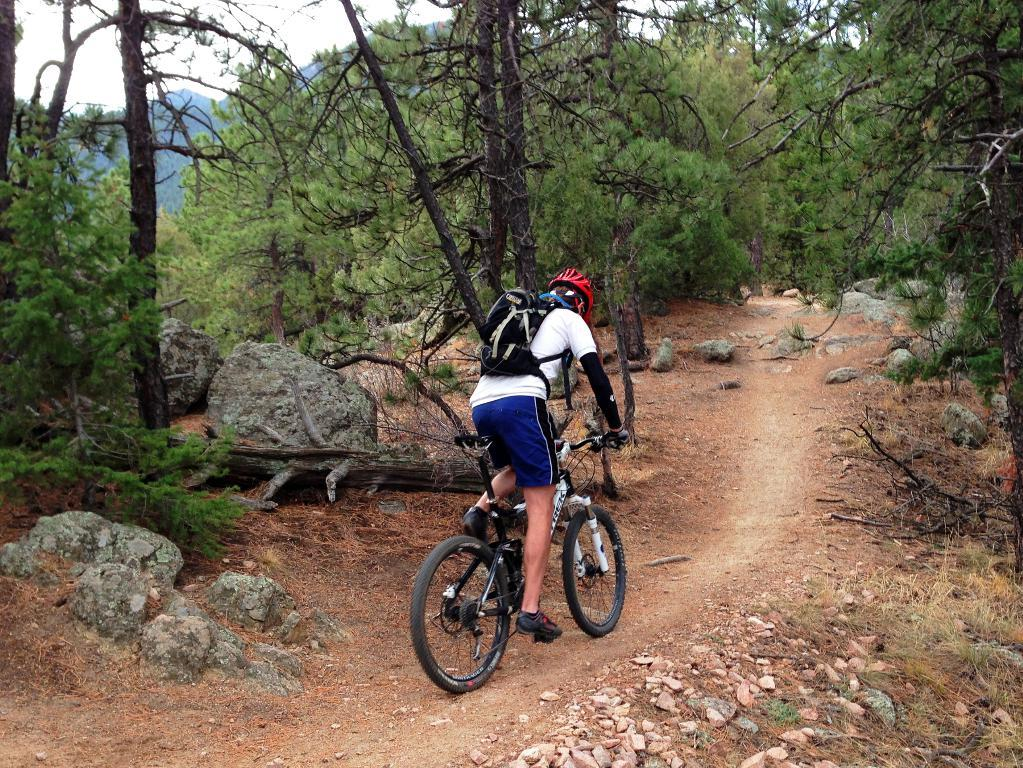What is the main subject of the image? There is a person riding a bicycle in the image. What type of terrain can be seen in the image? There are stones, grass, rocks, and trees visible in the image. What is the background of the image? There is a mountain and the sky visible in the background of the image. What type of joke is being told by the person riding the bicycle in the image? There is no indication in the image that the person riding the bicycle is telling a joke, so it cannot be determined from the picture. 